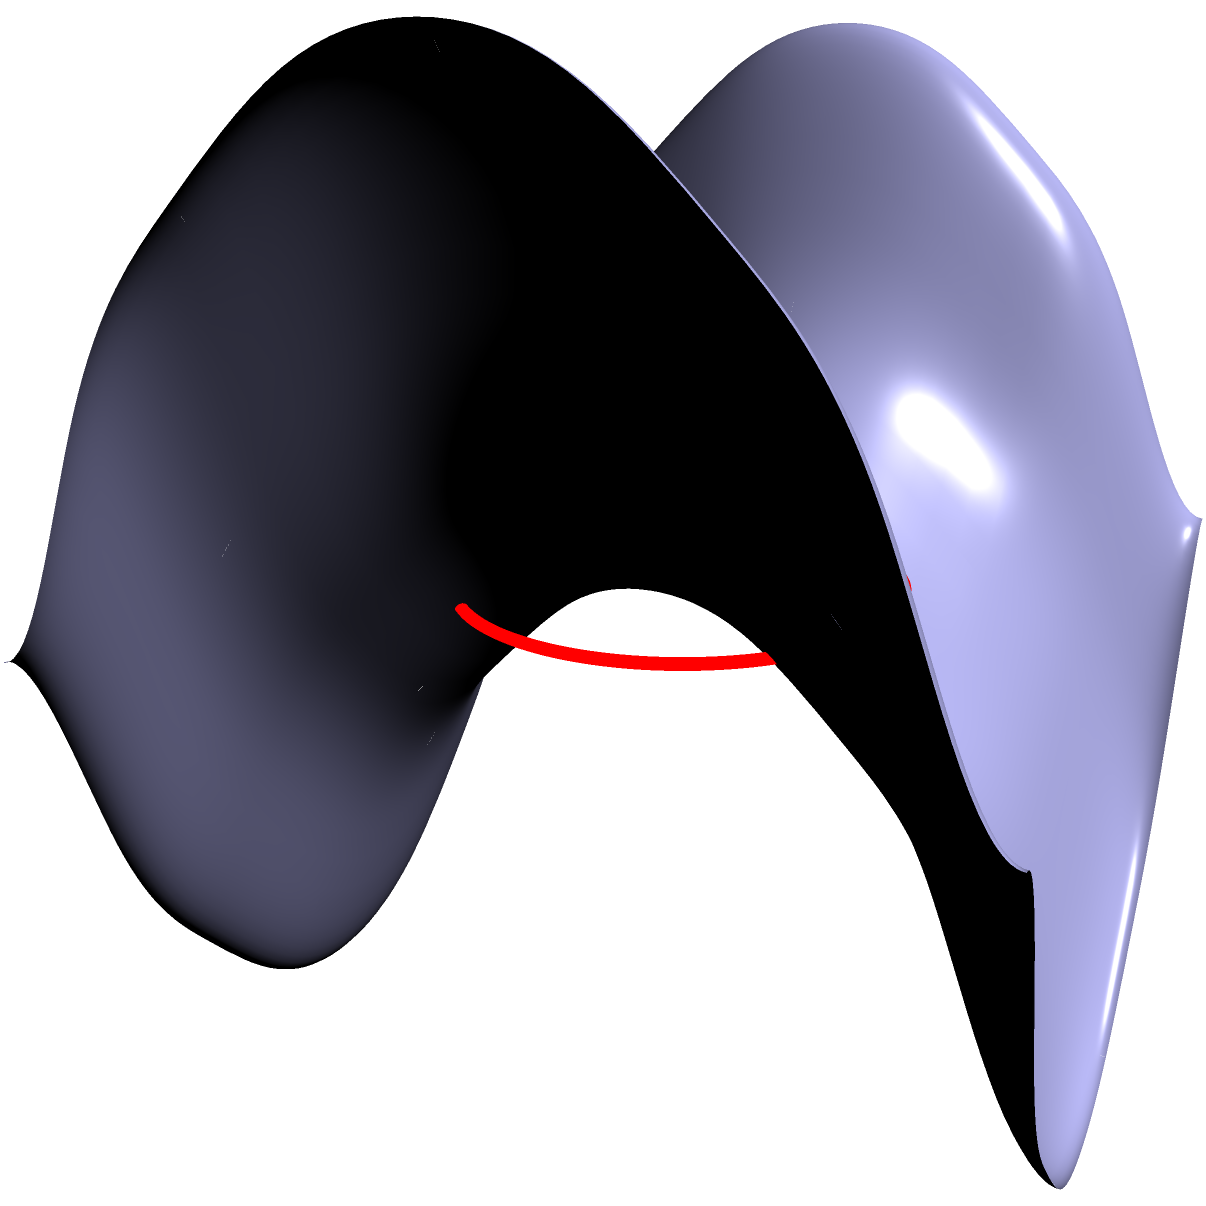As a human rights advocate overseeing forensic document examination, you encounter a case involving a non-Euclidean surface. The surface is a saddle-shaped manifold described by the equation $z = \frac{1}{2}(x^2 - y^2)$. A circle with radius $r$ is drawn on this surface, centered at the origin. How does the area of this circle differ from a standard Euclidean circle, and what factors should be considered when calculating its area? To understand the difference in area calculation for a circle on a non-Euclidean saddle-shaped manifold compared to a Euclidean plane, we need to consider the following steps:

1. Gaussian Curvature: The saddle-shaped manifold has a negative Gaussian curvature, which affects the geometry of shapes drawn on it.

2. Metric Tensor: The metric tensor for this surface is given by:
   $$g = \begin{pmatrix}
   1 + x^2 & 0 \\
   0 & 1 + y^2
   \end{pmatrix}$$

3. Area Element: The area element on this surface is:
   $$dA = \sqrt{\det(g)} \, dx \, dy = \sqrt{(1+x^2)(1+y^2)} \, dx \, dy$$

4. Circle Area Calculation: To find the area, we need to integrate the area element over the region of the circle:
   $$A = \int\int_D \sqrt{(1+x^2)(1+y^2)} \, dx \, dy$$
   where $D$ is the domain of integration (the circle's projection on the xy-plane).

5. Comparison to Euclidean Circle: In Euclidean geometry, the area would simply be $A = \pi r^2$. However, on this surface, the area will be larger due to the curvature.

6. Approximation: For small radii, we can approximate the area as:
   $$A \approx \pi r^2 (1 + \frac{1}{4}r^2 + O(r^4))$$

7. Considerations:
   - The area increases more rapidly with radius compared to a Euclidean circle.
   - The calculation becomes more complex for larger radii, requiring numerical integration.
   - The shape of the "circle" on the surface is actually distorted and not perfectly circular.

These factors are crucial when analyzing documents or evidence presented on non-standard surfaces in forensic examinations.
Answer: Area is larger than $\pi r^2$, approximately $\pi r^2 (1 + \frac{1}{4}r^2)$ for small $r$, due to negative curvature. 